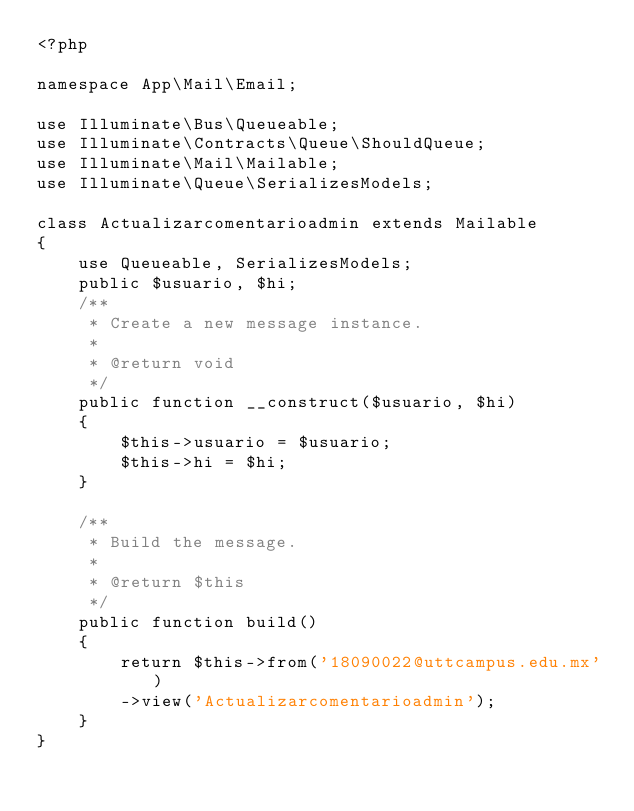<code> <loc_0><loc_0><loc_500><loc_500><_PHP_><?php

namespace App\Mail\Email;

use Illuminate\Bus\Queueable;
use Illuminate\Contracts\Queue\ShouldQueue;
use Illuminate\Mail\Mailable;
use Illuminate\Queue\SerializesModels;

class Actualizarcomentarioadmin extends Mailable
{
    use Queueable, SerializesModels;
    public $usuario, $hi;
    /**
     * Create a new message instance.
     *
     * @return void
     */
    public function __construct($usuario, $hi)
    {
        $this->usuario = $usuario;
        $this->hi = $hi;
    }

    /**
     * Build the message.
     *
     * @return $this
     */
    public function build()
    {
        return $this->from('18090022@uttcampus.edu.mx')
        ->view('Actualizarcomentarioadmin');
    }
}
</code> 